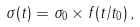<formula> <loc_0><loc_0><loc_500><loc_500>\sigma ( t ) = \sigma _ { 0 } \times f ( t / t _ { 0 } ) \, ,</formula> 